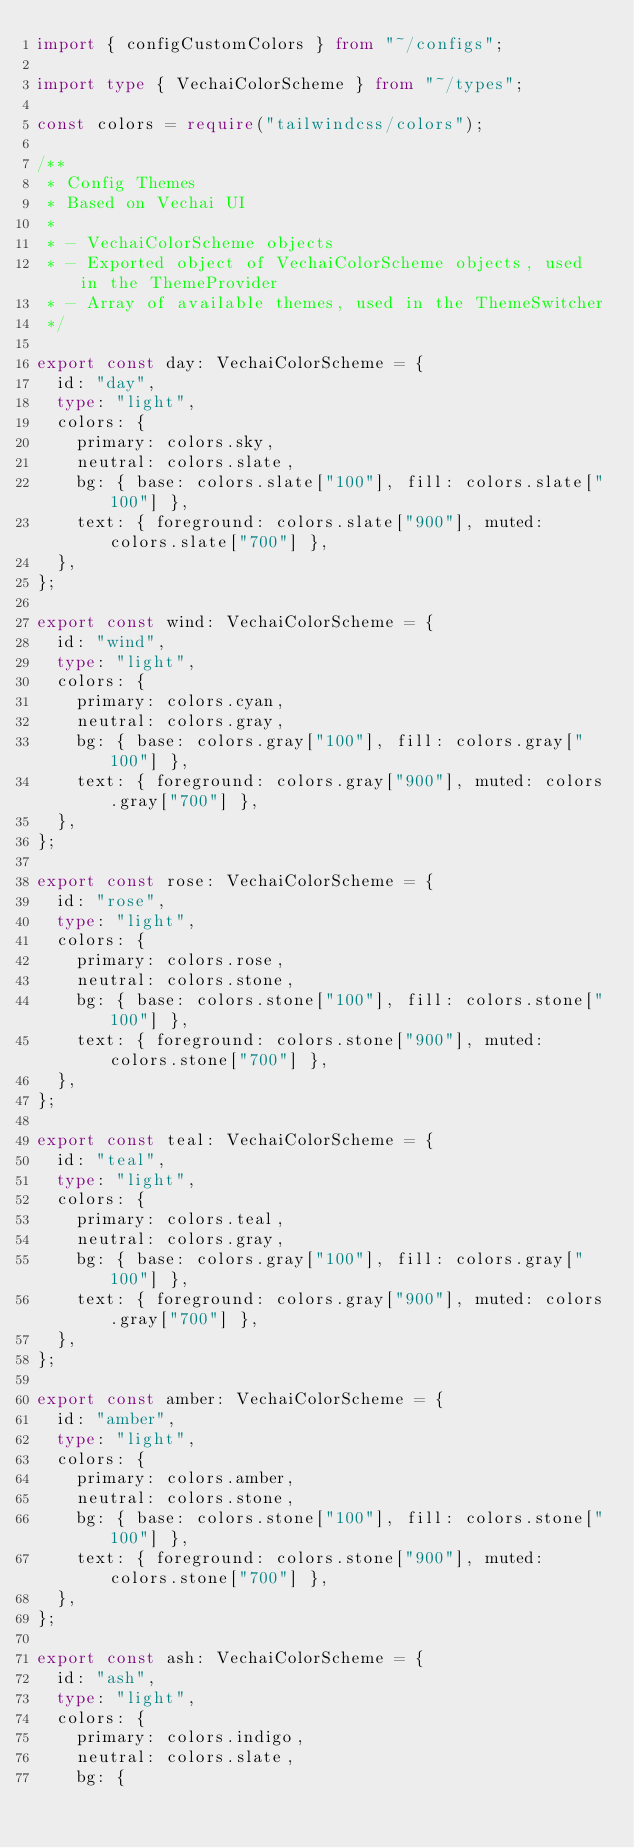<code> <loc_0><loc_0><loc_500><loc_500><_TypeScript_>import { configCustomColors } from "~/configs";

import type { VechaiColorScheme } from "~/types";

const colors = require("tailwindcss/colors");

/**
 * Config Themes
 * Based on Vechai UI
 *
 * - VechaiColorScheme objects
 * - Exported object of VechaiColorScheme objects, used in the ThemeProvider
 * - Array of available themes, used in the ThemeSwitcher
 */

export const day: VechaiColorScheme = {
  id: "day",
  type: "light",
  colors: {
    primary: colors.sky,
    neutral: colors.slate,
    bg: { base: colors.slate["100"], fill: colors.slate["100"] },
    text: { foreground: colors.slate["900"], muted: colors.slate["700"] },
  },
};

export const wind: VechaiColorScheme = {
  id: "wind",
  type: "light",
  colors: {
    primary: colors.cyan,
    neutral: colors.gray,
    bg: { base: colors.gray["100"], fill: colors.gray["100"] },
    text: { foreground: colors.gray["900"], muted: colors.gray["700"] },
  },
};

export const rose: VechaiColorScheme = {
  id: "rose",
  type: "light",
  colors: {
    primary: colors.rose,
    neutral: colors.stone,
    bg: { base: colors.stone["100"], fill: colors.stone["100"] },
    text: { foreground: colors.stone["900"], muted: colors.stone["700"] },
  },
};

export const teal: VechaiColorScheme = {
  id: "teal",
  type: "light",
  colors: {
    primary: colors.teal,
    neutral: colors.gray,
    bg: { base: colors.gray["100"], fill: colors.gray["100"] },
    text: { foreground: colors.gray["900"], muted: colors.gray["700"] },
  },
};

export const amber: VechaiColorScheme = {
  id: "amber",
  type: "light",
  colors: {
    primary: colors.amber,
    neutral: colors.stone,
    bg: { base: colors.stone["100"], fill: colors.stone["100"] },
    text: { foreground: colors.stone["900"], muted: colors.stone["700"] },
  },
};

export const ash: VechaiColorScheme = {
  id: "ash",
  type: "light",
  colors: {
    primary: colors.indigo,
    neutral: colors.slate,
    bg: {</code> 